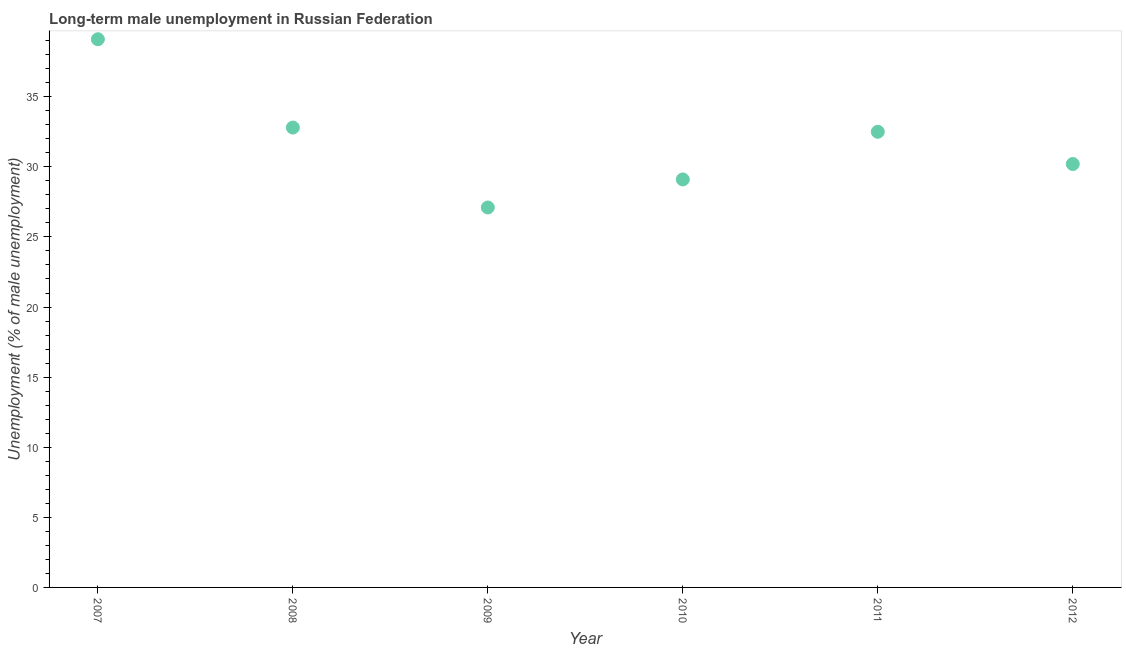What is the long-term male unemployment in 2010?
Your answer should be very brief. 29.1. Across all years, what is the maximum long-term male unemployment?
Offer a terse response. 39.1. Across all years, what is the minimum long-term male unemployment?
Provide a succinct answer. 27.1. What is the sum of the long-term male unemployment?
Provide a succinct answer. 190.8. What is the difference between the long-term male unemployment in 2008 and 2012?
Ensure brevity in your answer.  2.6. What is the average long-term male unemployment per year?
Your answer should be very brief. 31.8. What is the median long-term male unemployment?
Your response must be concise. 31.35. Do a majority of the years between 2010 and 2008 (inclusive) have long-term male unemployment greater than 18 %?
Offer a very short reply. No. What is the ratio of the long-term male unemployment in 2008 to that in 2012?
Your answer should be very brief. 1.09. Is the long-term male unemployment in 2007 less than that in 2012?
Keep it short and to the point. No. Is the difference between the long-term male unemployment in 2008 and 2011 greater than the difference between any two years?
Ensure brevity in your answer.  No. What is the difference between the highest and the second highest long-term male unemployment?
Give a very brief answer. 6.3. What is the difference between the highest and the lowest long-term male unemployment?
Ensure brevity in your answer.  12. In how many years, is the long-term male unemployment greater than the average long-term male unemployment taken over all years?
Offer a terse response. 3. How many dotlines are there?
Ensure brevity in your answer.  1. How many years are there in the graph?
Offer a very short reply. 6. Does the graph contain any zero values?
Offer a terse response. No. Does the graph contain grids?
Give a very brief answer. No. What is the title of the graph?
Provide a succinct answer. Long-term male unemployment in Russian Federation. What is the label or title of the X-axis?
Make the answer very short. Year. What is the label or title of the Y-axis?
Provide a short and direct response. Unemployment (% of male unemployment). What is the Unemployment (% of male unemployment) in 2007?
Ensure brevity in your answer.  39.1. What is the Unemployment (% of male unemployment) in 2008?
Provide a short and direct response. 32.8. What is the Unemployment (% of male unemployment) in 2009?
Give a very brief answer. 27.1. What is the Unemployment (% of male unemployment) in 2010?
Offer a very short reply. 29.1. What is the Unemployment (% of male unemployment) in 2011?
Provide a short and direct response. 32.5. What is the Unemployment (% of male unemployment) in 2012?
Make the answer very short. 30.2. What is the difference between the Unemployment (% of male unemployment) in 2007 and 2008?
Provide a short and direct response. 6.3. What is the difference between the Unemployment (% of male unemployment) in 2007 and 2009?
Give a very brief answer. 12. What is the difference between the Unemployment (% of male unemployment) in 2007 and 2010?
Give a very brief answer. 10. What is the difference between the Unemployment (% of male unemployment) in 2008 and 2009?
Your response must be concise. 5.7. What is the difference between the Unemployment (% of male unemployment) in 2010 and 2012?
Your response must be concise. -1.1. What is the difference between the Unemployment (% of male unemployment) in 2011 and 2012?
Give a very brief answer. 2.3. What is the ratio of the Unemployment (% of male unemployment) in 2007 to that in 2008?
Make the answer very short. 1.19. What is the ratio of the Unemployment (% of male unemployment) in 2007 to that in 2009?
Provide a short and direct response. 1.44. What is the ratio of the Unemployment (% of male unemployment) in 2007 to that in 2010?
Your response must be concise. 1.34. What is the ratio of the Unemployment (% of male unemployment) in 2007 to that in 2011?
Give a very brief answer. 1.2. What is the ratio of the Unemployment (% of male unemployment) in 2007 to that in 2012?
Your response must be concise. 1.29. What is the ratio of the Unemployment (% of male unemployment) in 2008 to that in 2009?
Offer a very short reply. 1.21. What is the ratio of the Unemployment (% of male unemployment) in 2008 to that in 2010?
Offer a terse response. 1.13. What is the ratio of the Unemployment (% of male unemployment) in 2008 to that in 2011?
Your response must be concise. 1.01. What is the ratio of the Unemployment (% of male unemployment) in 2008 to that in 2012?
Ensure brevity in your answer.  1.09. What is the ratio of the Unemployment (% of male unemployment) in 2009 to that in 2010?
Give a very brief answer. 0.93. What is the ratio of the Unemployment (% of male unemployment) in 2009 to that in 2011?
Give a very brief answer. 0.83. What is the ratio of the Unemployment (% of male unemployment) in 2009 to that in 2012?
Offer a terse response. 0.9. What is the ratio of the Unemployment (% of male unemployment) in 2010 to that in 2011?
Provide a succinct answer. 0.9. What is the ratio of the Unemployment (% of male unemployment) in 2011 to that in 2012?
Offer a very short reply. 1.08. 